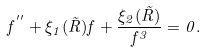<formula> <loc_0><loc_0><loc_500><loc_500>f ^ { ^ { \prime \prime } } + \xi _ { 1 } ( \tilde { R } ) f + \frac { \xi _ { 2 } ( \tilde { R } ) } { f ^ { 3 } } = 0 .</formula> 